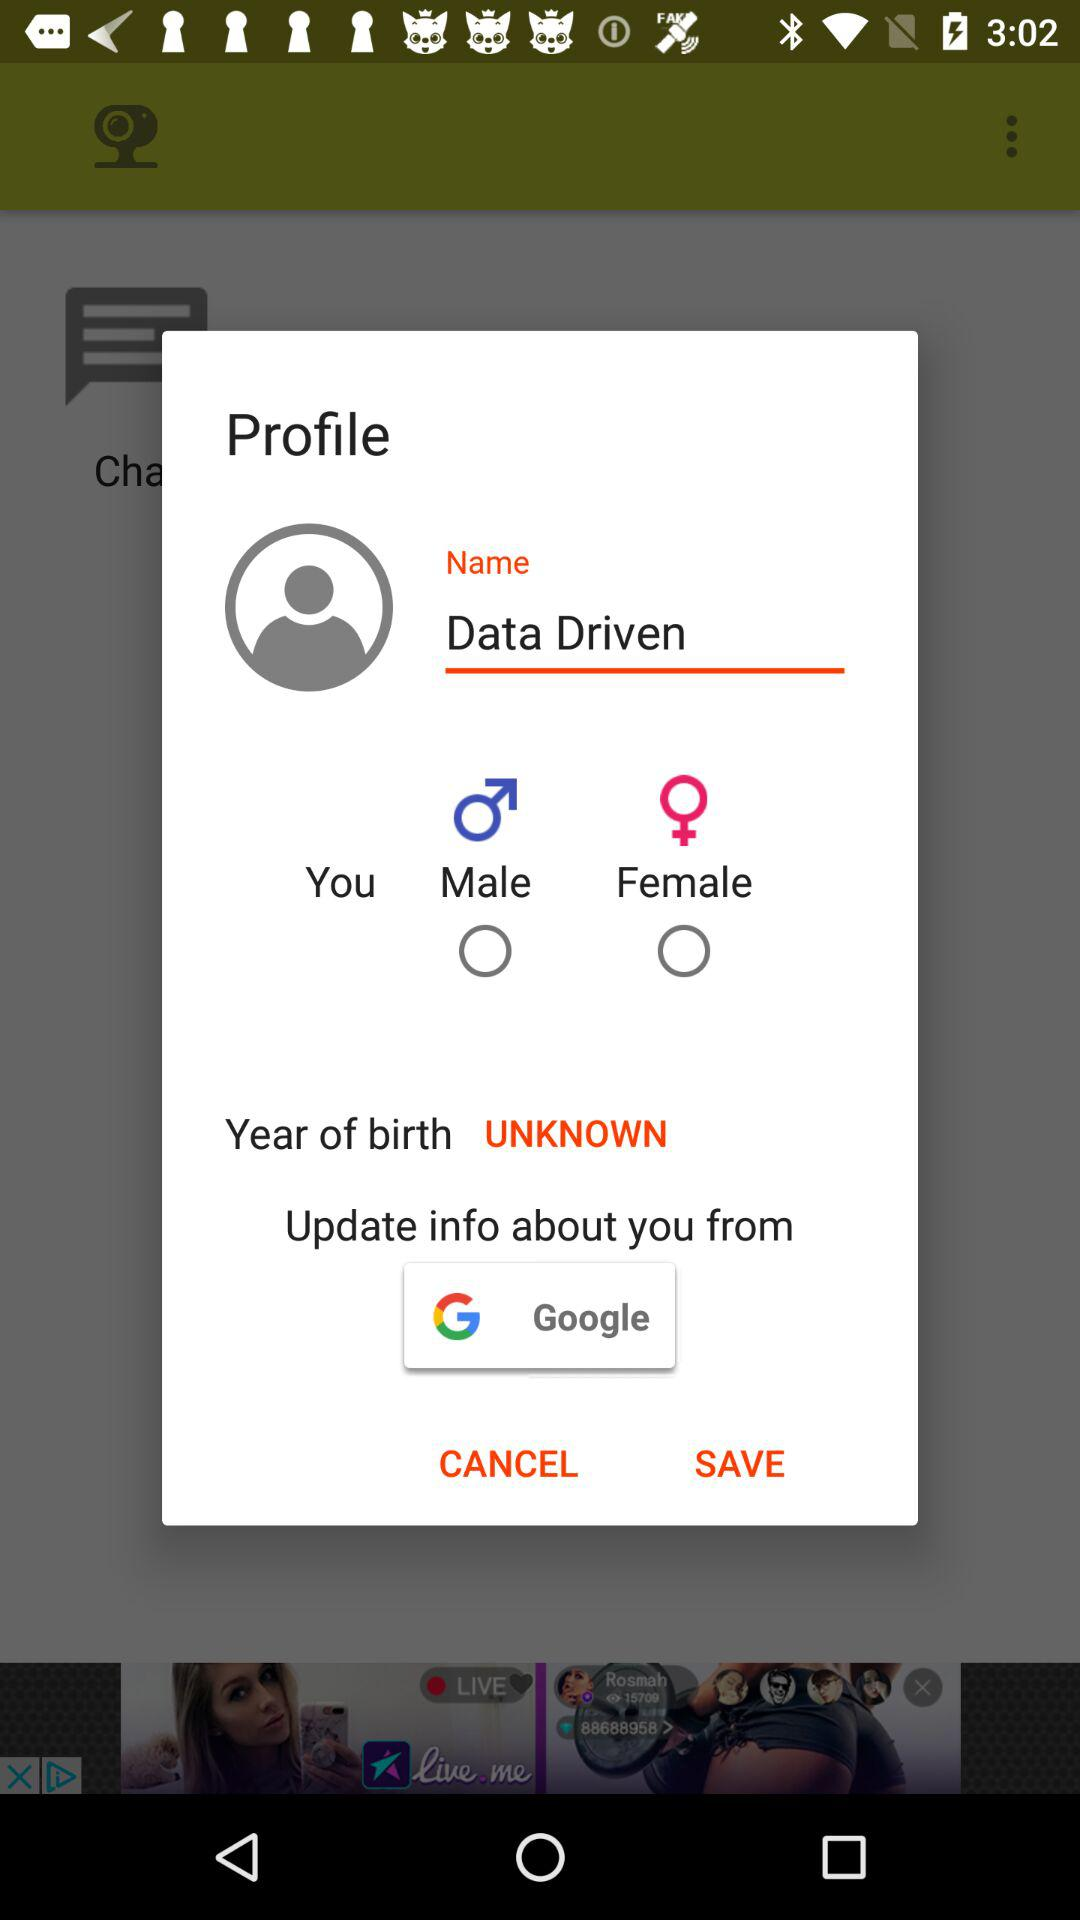Through what application can the user update their info? The user can update their info through "Google". 